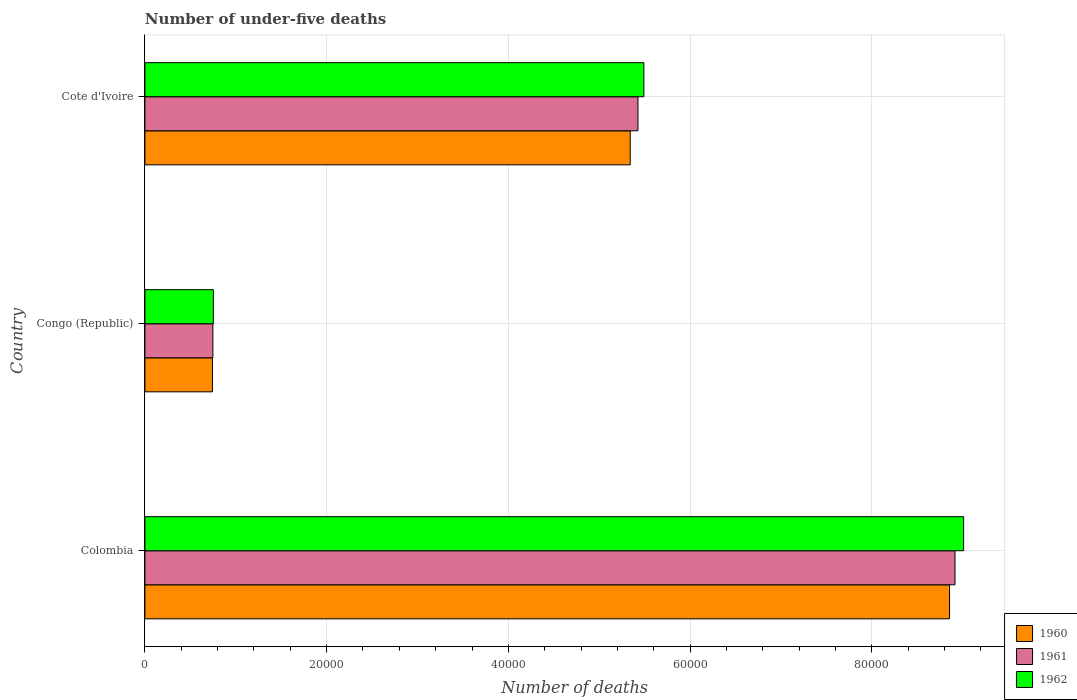Are the number of bars per tick equal to the number of legend labels?
Your answer should be compact. Yes. How many bars are there on the 1st tick from the top?
Make the answer very short. 3. How many bars are there on the 3rd tick from the bottom?
Ensure brevity in your answer.  3. What is the label of the 3rd group of bars from the top?
Ensure brevity in your answer.  Colombia. In how many cases, is the number of bars for a given country not equal to the number of legend labels?
Your answer should be very brief. 0. What is the number of under-five deaths in 1961 in Colombia?
Your response must be concise. 8.92e+04. Across all countries, what is the maximum number of under-five deaths in 1962?
Offer a very short reply. 9.01e+04. Across all countries, what is the minimum number of under-five deaths in 1962?
Make the answer very short. 7530. In which country was the number of under-five deaths in 1962 minimum?
Your answer should be compact. Congo (Republic). What is the total number of under-five deaths in 1960 in the graph?
Your response must be concise. 1.49e+05. What is the difference between the number of under-five deaths in 1962 in Congo (Republic) and that in Cote d'Ivoire?
Provide a short and direct response. -4.74e+04. What is the difference between the number of under-five deaths in 1960 in Congo (Republic) and the number of under-five deaths in 1961 in Cote d'Ivoire?
Make the answer very short. -4.68e+04. What is the average number of under-five deaths in 1962 per country?
Your answer should be very brief. 5.08e+04. In how many countries, is the number of under-five deaths in 1962 greater than 72000 ?
Give a very brief answer. 1. What is the ratio of the number of under-five deaths in 1962 in Colombia to that in Congo (Republic)?
Offer a very short reply. 11.97. Is the difference between the number of under-five deaths in 1961 in Colombia and Cote d'Ivoire greater than the difference between the number of under-five deaths in 1962 in Colombia and Cote d'Ivoire?
Make the answer very short. No. What is the difference between the highest and the second highest number of under-five deaths in 1960?
Your answer should be compact. 3.51e+04. What is the difference between the highest and the lowest number of under-five deaths in 1962?
Ensure brevity in your answer.  8.26e+04. What does the 2nd bar from the bottom in Cote d'Ivoire represents?
Ensure brevity in your answer.  1961. Is it the case that in every country, the sum of the number of under-five deaths in 1960 and number of under-five deaths in 1962 is greater than the number of under-five deaths in 1961?
Your answer should be compact. Yes. How many countries are there in the graph?
Offer a very short reply. 3. Does the graph contain any zero values?
Give a very brief answer. No. Does the graph contain grids?
Offer a terse response. Yes. What is the title of the graph?
Make the answer very short. Number of under-five deaths. Does "1965" appear as one of the legend labels in the graph?
Your response must be concise. No. What is the label or title of the X-axis?
Your response must be concise. Number of deaths. What is the label or title of the Y-axis?
Your answer should be compact. Country. What is the Number of deaths of 1960 in Colombia?
Your response must be concise. 8.86e+04. What is the Number of deaths in 1961 in Colombia?
Provide a short and direct response. 8.92e+04. What is the Number of deaths of 1962 in Colombia?
Ensure brevity in your answer.  9.01e+04. What is the Number of deaths of 1960 in Congo (Republic)?
Keep it short and to the point. 7431. What is the Number of deaths of 1961 in Congo (Republic)?
Your answer should be very brief. 7480. What is the Number of deaths of 1962 in Congo (Republic)?
Your response must be concise. 7530. What is the Number of deaths in 1960 in Cote d'Ivoire?
Offer a terse response. 5.34e+04. What is the Number of deaths of 1961 in Cote d'Ivoire?
Make the answer very short. 5.43e+04. What is the Number of deaths in 1962 in Cote d'Ivoire?
Provide a short and direct response. 5.49e+04. Across all countries, what is the maximum Number of deaths of 1960?
Make the answer very short. 8.86e+04. Across all countries, what is the maximum Number of deaths in 1961?
Offer a very short reply. 8.92e+04. Across all countries, what is the maximum Number of deaths in 1962?
Ensure brevity in your answer.  9.01e+04. Across all countries, what is the minimum Number of deaths in 1960?
Provide a succinct answer. 7431. Across all countries, what is the minimum Number of deaths in 1961?
Give a very brief answer. 7480. Across all countries, what is the minimum Number of deaths of 1962?
Your response must be concise. 7530. What is the total Number of deaths of 1960 in the graph?
Give a very brief answer. 1.49e+05. What is the total Number of deaths in 1961 in the graph?
Make the answer very short. 1.51e+05. What is the total Number of deaths in 1962 in the graph?
Your answer should be very brief. 1.53e+05. What is the difference between the Number of deaths in 1960 in Colombia and that in Congo (Republic)?
Give a very brief answer. 8.11e+04. What is the difference between the Number of deaths of 1961 in Colombia and that in Congo (Republic)?
Offer a very short reply. 8.17e+04. What is the difference between the Number of deaths of 1962 in Colombia and that in Congo (Republic)?
Provide a succinct answer. 8.26e+04. What is the difference between the Number of deaths of 1960 in Colombia and that in Cote d'Ivoire?
Provide a short and direct response. 3.51e+04. What is the difference between the Number of deaths of 1961 in Colombia and that in Cote d'Ivoire?
Give a very brief answer. 3.49e+04. What is the difference between the Number of deaths in 1962 in Colombia and that in Cote d'Ivoire?
Offer a very short reply. 3.52e+04. What is the difference between the Number of deaths in 1960 in Congo (Republic) and that in Cote d'Ivoire?
Give a very brief answer. -4.60e+04. What is the difference between the Number of deaths in 1961 in Congo (Republic) and that in Cote d'Ivoire?
Offer a very short reply. -4.68e+04. What is the difference between the Number of deaths of 1962 in Congo (Republic) and that in Cote d'Ivoire?
Offer a terse response. -4.74e+04. What is the difference between the Number of deaths in 1960 in Colombia and the Number of deaths in 1961 in Congo (Republic)?
Provide a succinct answer. 8.11e+04. What is the difference between the Number of deaths in 1960 in Colombia and the Number of deaths in 1962 in Congo (Republic)?
Your answer should be compact. 8.10e+04. What is the difference between the Number of deaths of 1961 in Colombia and the Number of deaths of 1962 in Congo (Republic)?
Give a very brief answer. 8.16e+04. What is the difference between the Number of deaths of 1960 in Colombia and the Number of deaths of 1961 in Cote d'Ivoire?
Offer a terse response. 3.43e+04. What is the difference between the Number of deaths of 1960 in Colombia and the Number of deaths of 1962 in Cote d'Ivoire?
Keep it short and to the point. 3.36e+04. What is the difference between the Number of deaths in 1961 in Colombia and the Number of deaths in 1962 in Cote d'Ivoire?
Your answer should be very brief. 3.42e+04. What is the difference between the Number of deaths in 1960 in Congo (Republic) and the Number of deaths in 1961 in Cote d'Ivoire?
Make the answer very short. -4.68e+04. What is the difference between the Number of deaths in 1960 in Congo (Republic) and the Number of deaths in 1962 in Cote d'Ivoire?
Give a very brief answer. -4.75e+04. What is the difference between the Number of deaths in 1961 in Congo (Republic) and the Number of deaths in 1962 in Cote d'Ivoire?
Make the answer very short. -4.74e+04. What is the average Number of deaths of 1960 per country?
Provide a succinct answer. 4.98e+04. What is the average Number of deaths of 1961 per country?
Your answer should be compact. 5.03e+04. What is the average Number of deaths of 1962 per country?
Offer a terse response. 5.08e+04. What is the difference between the Number of deaths in 1960 and Number of deaths in 1961 in Colombia?
Make the answer very short. -600. What is the difference between the Number of deaths of 1960 and Number of deaths of 1962 in Colombia?
Your answer should be compact. -1548. What is the difference between the Number of deaths in 1961 and Number of deaths in 1962 in Colombia?
Your response must be concise. -948. What is the difference between the Number of deaths of 1960 and Number of deaths of 1961 in Congo (Republic)?
Your answer should be compact. -49. What is the difference between the Number of deaths in 1960 and Number of deaths in 1962 in Congo (Republic)?
Your answer should be very brief. -99. What is the difference between the Number of deaths in 1960 and Number of deaths in 1961 in Cote d'Ivoire?
Your answer should be very brief. -852. What is the difference between the Number of deaths of 1960 and Number of deaths of 1962 in Cote d'Ivoire?
Offer a terse response. -1500. What is the difference between the Number of deaths of 1961 and Number of deaths of 1962 in Cote d'Ivoire?
Provide a succinct answer. -648. What is the ratio of the Number of deaths of 1960 in Colombia to that in Congo (Republic)?
Your response must be concise. 11.92. What is the ratio of the Number of deaths in 1961 in Colombia to that in Congo (Republic)?
Your response must be concise. 11.92. What is the ratio of the Number of deaths in 1962 in Colombia to that in Congo (Republic)?
Offer a terse response. 11.97. What is the ratio of the Number of deaths in 1960 in Colombia to that in Cote d'Ivoire?
Offer a terse response. 1.66. What is the ratio of the Number of deaths in 1961 in Colombia to that in Cote d'Ivoire?
Your answer should be compact. 1.64. What is the ratio of the Number of deaths in 1962 in Colombia to that in Cote d'Ivoire?
Your answer should be very brief. 1.64. What is the ratio of the Number of deaths in 1960 in Congo (Republic) to that in Cote d'Ivoire?
Provide a succinct answer. 0.14. What is the ratio of the Number of deaths of 1961 in Congo (Republic) to that in Cote d'Ivoire?
Provide a short and direct response. 0.14. What is the ratio of the Number of deaths of 1962 in Congo (Republic) to that in Cote d'Ivoire?
Make the answer very short. 0.14. What is the difference between the highest and the second highest Number of deaths in 1960?
Give a very brief answer. 3.51e+04. What is the difference between the highest and the second highest Number of deaths of 1961?
Give a very brief answer. 3.49e+04. What is the difference between the highest and the second highest Number of deaths of 1962?
Your answer should be compact. 3.52e+04. What is the difference between the highest and the lowest Number of deaths in 1960?
Your answer should be compact. 8.11e+04. What is the difference between the highest and the lowest Number of deaths of 1961?
Give a very brief answer. 8.17e+04. What is the difference between the highest and the lowest Number of deaths in 1962?
Your answer should be compact. 8.26e+04. 